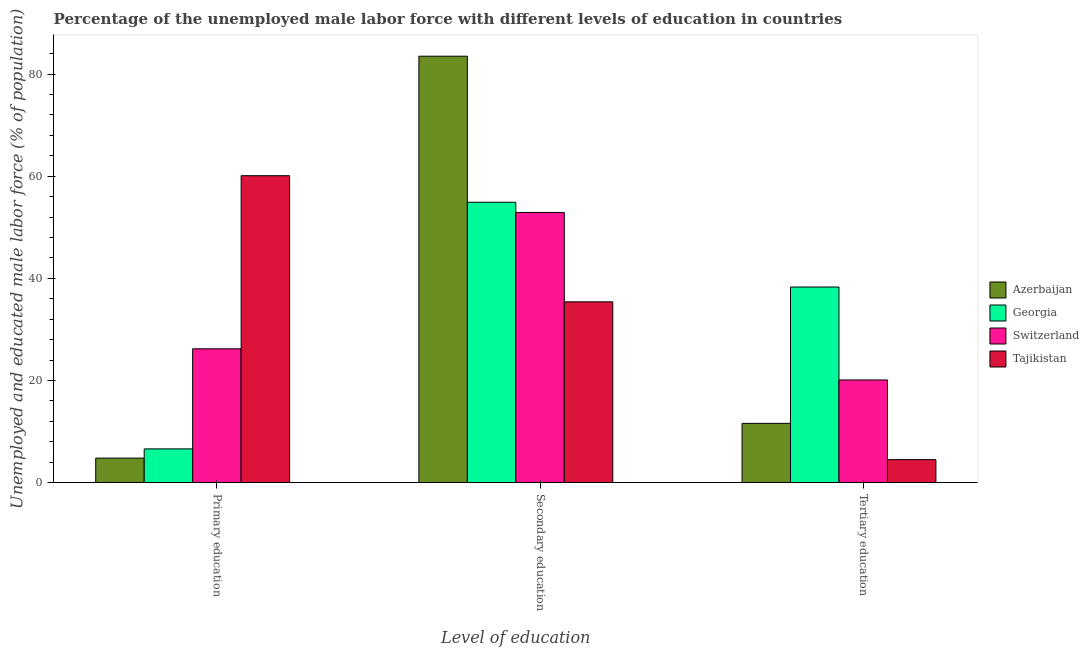How many different coloured bars are there?
Keep it short and to the point. 4. How many groups of bars are there?
Give a very brief answer. 3. Are the number of bars on each tick of the X-axis equal?
Your response must be concise. Yes. What is the label of the 3rd group of bars from the left?
Provide a short and direct response. Tertiary education. What is the percentage of male labor force who received secondary education in Tajikistan?
Ensure brevity in your answer.  35.4. Across all countries, what is the maximum percentage of male labor force who received tertiary education?
Make the answer very short. 38.3. In which country was the percentage of male labor force who received primary education maximum?
Ensure brevity in your answer.  Tajikistan. In which country was the percentage of male labor force who received tertiary education minimum?
Provide a short and direct response. Tajikistan. What is the total percentage of male labor force who received primary education in the graph?
Provide a short and direct response. 97.7. What is the difference between the percentage of male labor force who received tertiary education in Azerbaijan and that in Switzerland?
Your answer should be very brief. -8.5. What is the difference between the percentage of male labor force who received secondary education in Azerbaijan and the percentage of male labor force who received tertiary education in Switzerland?
Your response must be concise. 63.4. What is the average percentage of male labor force who received secondary education per country?
Your answer should be very brief. 56.68. What is the difference between the percentage of male labor force who received secondary education and percentage of male labor force who received primary education in Tajikistan?
Your answer should be compact. -24.7. What is the ratio of the percentage of male labor force who received secondary education in Azerbaijan to that in Switzerland?
Your answer should be compact. 1.58. What is the difference between the highest and the second highest percentage of male labor force who received primary education?
Offer a very short reply. 33.9. What is the difference between the highest and the lowest percentage of male labor force who received primary education?
Your answer should be compact. 55.3. In how many countries, is the percentage of male labor force who received secondary education greater than the average percentage of male labor force who received secondary education taken over all countries?
Ensure brevity in your answer.  1. What does the 4th bar from the left in Primary education represents?
Make the answer very short. Tajikistan. What does the 4th bar from the right in Secondary education represents?
Keep it short and to the point. Azerbaijan. How many bars are there?
Give a very brief answer. 12. Are all the bars in the graph horizontal?
Your answer should be very brief. No. How many countries are there in the graph?
Make the answer very short. 4. What is the difference between two consecutive major ticks on the Y-axis?
Give a very brief answer. 20. Does the graph contain any zero values?
Keep it short and to the point. No. Does the graph contain grids?
Ensure brevity in your answer.  No. How are the legend labels stacked?
Provide a succinct answer. Vertical. What is the title of the graph?
Provide a short and direct response. Percentage of the unemployed male labor force with different levels of education in countries. What is the label or title of the X-axis?
Your answer should be very brief. Level of education. What is the label or title of the Y-axis?
Offer a terse response. Unemployed and educated male labor force (% of population). What is the Unemployed and educated male labor force (% of population) of Azerbaijan in Primary education?
Your answer should be very brief. 4.8. What is the Unemployed and educated male labor force (% of population) in Georgia in Primary education?
Your response must be concise. 6.6. What is the Unemployed and educated male labor force (% of population) in Switzerland in Primary education?
Provide a short and direct response. 26.2. What is the Unemployed and educated male labor force (% of population) of Tajikistan in Primary education?
Your response must be concise. 60.1. What is the Unemployed and educated male labor force (% of population) of Azerbaijan in Secondary education?
Your answer should be compact. 83.5. What is the Unemployed and educated male labor force (% of population) in Georgia in Secondary education?
Ensure brevity in your answer.  54.9. What is the Unemployed and educated male labor force (% of population) in Switzerland in Secondary education?
Your response must be concise. 52.9. What is the Unemployed and educated male labor force (% of population) of Tajikistan in Secondary education?
Your answer should be very brief. 35.4. What is the Unemployed and educated male labor force (% of population) in Azerbaijan in Tertiary education?
Provide a succinct answer. 11.6. What is the Unemployed and educated male labor force (% of population) in Georgia in Tertiary education?
Your answer should be very brief. 38.3. What is the Unemployed and educated male labor force (% of population) in Switzerland in Tertiary education?
Keep it short and to the point. 20.1. Across all Level of education, what is the maximum Unemployed and educated male labor force (% of population) of Azerbaijan?
Your answer should be compact. 83.5. Across all Level of education, what is the maximum Unemployed and educated male labor force (% of population) in Georgia?
Provide a succinct answer. 54.9. Across all Level of education, what is the maximum Unemployed and educated male labor force (% of population) of Switzerland?
Offer a terse response. 52.9. Across all Level of education, what is the maximum Unemployed and educated male labor force (% of population) of Tajikistan?
Offer a terse response. 60.1. Across all Level of education, what is the minimum Unemployed and educated male labor force (% of population) in Azerbaijan?
Make the answer very short. 4.8. Across all Level of education, what is the minimum Unemployed and educated male labor force (% of population) of Georgia?
Keep it short and to the point. 6.6. Across all Level of education, what is the minimum Unemployed and educated male labor force (% of population) of Switzerland?
Give a very brief answer. 20.1. Across all Level of education, what is the minimum Unemployed and educated male labor force (% of population) of Tajikistan?
Your response must be concise. 4.5. What is the total Unemployed and educated male labor force (% of population) in Azerbaijan in the graph?
Provide a short and direct response. 99.9. What is the total Unemployed and educated male labor force (% of population) of Georgia in the graph?
Offer a terse response. 99.8. What is the total Unemployed and educated male labor force (% of population) of Switzerland in the graph?
Your response must be concise. 99.2. What is the total Unemployed and educated male labor force (% of population) in Tajikistan in the graph?
Keep it short and to the point. 100. What is the difference between the Unemployed and educated male labor force (% of population) in Azerbaijan in Primary education and that in Secondary education?
Offer a very short reply. -78.7. What is the difference between the Unemployed and educated male labor force (% of population) of Georgia in Primary education and that in Secondary education?
Your response must be concise. -48.3. What is the difference between the Unemployed and educated male labor force (% of population) in Switzerland in Primary education and that in Secondary education?
Keep it short and to the point. -26.7. What is the difference between the Unemployed and educated male labor force (% of population) in Tajikistan in Primary education and that in Secondary education?
Your answer should be very brief. 24.7. What is the difference between the Unemployed and educated male labor force (% of population) in Azerbaijan in Primary education and that in Tertiary education?
Give a very brief answer. -6.8. What is the difference between the Unemployed and educated male labor force (% of population) of Georgia in Primary education and that in Tertiary education?
Provide a succinct answer. -31.7. What is the difference between the Unemployed and educated male labor force (% of population) of Tajikistan in Primary education and that in Tertiary education?
Your answer should be compact. 55.6. What is the difference between the Unemployed and educated male labor force (% of population) of Azerbaijan in Secondary education and that in Tertiary education?
Give a very brief answer. 71.9. What is the difference between the Unemployed and educated male labor force (% of population) in Switzerland in Secondary education and that in Tertiary education?
Ensure brevity in your answer.  32.8. What is the difference between the Unemployed and educated male labor force (% of population) of Tajikistan in Secondary education and that in Tertiary education?
Keep it short and to the point. 30.9. What is the difference between the Unemployed and educated male labor force (% of population) in Azerbaijan in Primary education and the Unemployed and educated male labor force (% of population) in Georgia in Secondary education?
Ensure brevity in your answer.  -50.1. What is the difference between the Unemployed and educated male labor force (% of population) of Azerbaijan in Primary education and the Unemployed and educated male labor force (% of population) of Switzerland in Secondary education?
Your answer should be very brief. -48.1. What is the difference between the Unemployed and educated male labor force (% of population) of Azerbaijan in Primary education and the Unemployed and educated male labor force (% of population) of Tajikistan in Secondary education?
Provide a succinct answer. -30.6. What is the difference between the Unemployed and educated male labor force (% of population) of Georgia in Primary education and the Unemployed and educated male labor force (% of population) of Switzerland in Secondary education?
Give a very brief answer. -46.3. What is the difference between the Unemployed and educated male labor force (% of population) in Georgia in Primary education and the Unemployed and educated male labor force (% of population) in Tajikistan in Secondary education?
Keep it short and to the point. -28.8. What is the difference between the Unemployed and educated male labor force (% of population) of Switzerland in Primary education and the Unemployed and educated male labor force (% of population) of Tajikistan in Secondary education?
Make the answer very short. -9.2. What is the difference between the Unemployed and educated male labor force (% of population) of Azerbaijan in Primary education and the Unemployed and educated male labor force (% of population) of Georgia in Tertiary education?
Provide a short and direct response. -33.5. What is the difference between the Unemployed and educated male labor force (% of population) of Azerbaijan in Primary education and the Unemployed and educated male labor force (% of population) of Switzerland in Tertiary education?
Provide a succinct answer. -15.3. What is the difference between the Unemployed and educated male labor force (% of population) in Georgia in Primary education and the Unemployed and educated male labor force (% of population) in Switzerland in Tertiary education?
Keep it short and to the point. -13.5. What is the difference between the Unemployed and educated male labor force (% of population) in Georgia in Primary education and the Unemployed and educated male labor force (% of population) in Tajikistan in Tertiary education?
Make the answer very short. 2.1. What is the difference between the Unemployed and educated male labor force (% of population) in Switzerland in Primary education and the Unemployed and educated male labor force (% of population) in Tajikistan in Tertiary education?
Your answer should be compact. 21.7. What is the difference between the Unemployed and educated male labor force (% of population) of Azerbaijan in Secondary education and the Unemployed and educated male labor force (% of population) of Georgia in Tertiary education?
Make the answer very short. 45.2. What is the difference between the Unemployed and educated male labor force (% of population) in Azerbaijan in Secondary education and the Unemployed and educated male labor force (% of population) in Switzerland in Tertiary education?
Keep it short and to the point. 63.4. What is the difference between the Unemployed and educated male labor force (% of population) in Azerbaijan in Secondary education and the Unemployed and educated male labor force (% of population) in Tajikistan in Tertiary education?
Keep it short and to the point. 79. What is the difference between the Unemployed and educated male labor force (% of population) in Georgia in Secondary education and the Unemployed and educated male labor force (% of population) in Switzerland in Tertiary education?
Your response must be concise. 34.8. What is the difference between the Unemployed and educated male labor force (% of population) of Georgia in Secondary education and the Unemployed and educated male labor force (% of population) of Tajikistan in Tertiary education?
Provide a short and direct response. 50.4. What is the difference between the Unemployed and educated male labor force (% of population) of Switzerland in Secondary education and the Unemployed and educated male labor force (% of population) of Tajikistan in Tertiary education?
Give a very brief answer. 48.4. What is the average Unemployed and educated male labor force (% of population) of Azerbaijan per Level of education?
Keep it short and to the point. 33.3. What is the average Unemployed and educated male labor force (% of population) of Georgia per Level of education?
Your answer should be very brief. 33.27. What is the average Unemployed and educated male labor force (% of population) in Switzerland per Level of education?
Offer a very short reply. 33.07. What is the average Unemployed and educated male labor force (% of population) of Tajikistan per Level of education?
Your answer should be very brief. 33.33. What is the difference between the Unemployed and educated male labor force (% of population) of Azerbaijan and Unemployed and educated male labor force (% of population) of Switzerland in Primary education?
Your answer should be very brief. -21.4. What is the difference between the Unemployed and educated male labor force (% of population) in Azerbaijan and Unemployed and educated male labor force (% of population) in Tajikistan in Primary education?
Ensure brevity in your answer.  -55.3. What is the difference between the Unemployed and educated male labor force (% of population) in Georgia and Unemployed and educated male labor force (% of population) in Switzerland in Primary education?
Your answer should be compact. -19.6. What is the difference between the Unemployed and educated male labor force (% of population) in Georgia and Unemployed and educated male labor force (% of population) in Tajikistan in Primary education?
Give a very brief answer. -53.5. What is the difference between the Unemployed and educated male labor force (% of population) of Switzerland and Unemployed and educated male labor force (% of population) of Tajikistan in Primary education?
Provide a succinct answer. -33.9. What is the difference between the Unemployed and educated male labor force (% of population) of Azerbaijan and Unemployed and educated male labor force (% of population) of Georgia in Secondary education?
Keep it short and to the point. 28.6. What is the difference between the Unemployed and educated male labor force (% of population) in Azerbaijan and Unemployed and educated male labor force (% of population) in Switzerland in Secondary education?
Make the answer very short. 30.6. What is the difference between the Unemployed and educated male labor force (% of population) in Azerbaijan and Unemployed and educated male labor force (% of population) in Tajikistan in Secondary education?
Make the answer very short. 48.1. What is the difference between the Unemployed and educated male labor force (% of population) in Georgia and Unemployed and educated male labor force (% of population) in Tajikistan in Secondary education?
Make the answer very short. 19.5. What is the difference between the Unemployed and educated male labor force (% of population) of Azerbaijan and Unemployed and educated male labor force (% of population) of Georgia in Tertiary education?
Give a very brief answer. -26.7. What is the difference between the Unemployed and educated male labor force (% of population) in Georgia and Unemployed and educated male labor force (% of population) in Switzerland in Tertiary education?
Your response must be concise. 18.2. What is the difference between the Unemployed and educated male labor force (% of population) in Georgia and Unemployed and educated male labor force (% of population) in Tajikistan in Tertiary education?
Give a very brief answer. 33.8. What is the difference between the Unemployed and educated male labor force (% of population) in Switzerland and Unemployed and educated male labor force (% of population) in Tajikistan in Tertiary education?
Ensure brevity in your answer.  15.6. What is the ratio of the Unemployed and educated male labor force (% of population) in Azerbaijan in Primary education to that in Secondary education?
Provide a succinct answer. 0.06. What is the ratio of the Unemployed and educated male labor force (% of population) in Georgia in Primary education to that in Secondary education?
Give a very brief answer. 0.12. What is the ratio of the Unemployed and educated male labor force (% of population) in Switzerland in Primary education to that in Secondary education?
Give a very brief answer. 0.5. What is the ratio of the Unemployed and educated male labor force (% of population) of Tajikistan in Primary education to that in Secondary education?
Make the answer very short. 1.7. What is the ratio of the Unemployed and educated male labor force (% of population) of Azerbaijan in Primary education to that in Tertiary education?
Keep it short and to the point. 0.41. What is the ratio of the Unemployed and educated male labor force (% of population) in Georgia in Primary education to that in Tertiary education?
Offer a very short reply. 0.17. What is the ratio of the Unemployed and educated male labor force (% of population) in Switzerland in Primary education to that in Tertiary education?
Provide a succinct answer. 1.3. What is the ratio of the Unemployed and educated male labor force (% of population) in Tajikistan in Primary education to that in Tertiary education?
Provide a succinct answer. 13.36. What is the ratio of the Unemployed and educated male labor force (% of population) of Azerbaijan in Secondary education to that in Tertiary education?
Offer a terse response. 7.2. What is the ratio of the Unemployed and educated male labor force (% of population) of Georgia in Secondary education to that in Tertiary education?
Keep it short and to the point. 1.43. What is the ratio of the Unemployed and educated male labor force (% of population) of Switzerland in Secondary education to that in Tertiary education?
Provide a succinct answer. 2.63. What is the ratio of the Unemployed and educated male labor force (% of population) of Tajikistan in Secondary education to that in Tertiary education?
Offer a very short reply. 7.87. What is the difference between the highest and the second highest Unemployed and educated male labor force (% of population) of Azerbaijan?
Keep it short and to the point. 71.9. What is the difference between the highest and the second highest Unemployed and educated male labor force (% of population) in Switzerland?
Your answer should be very brief. 26.7. What is the difference between the highest and the second highest Unemployed and educated male labor force (% of population) in Tajikistan?
Your answer should be compact. 24.7. What is the difference between the highest and the lowest Unemployed and educated male labor force (% of population) of Azerbaijan?
Offer a terse response. 78.7. What is the difference between the highest and the lowest Unemployed and educated male labor force (% of population) in Georgia?
Provide a succinct answer. 48.3. What is the difference between the highest and the lowest Unemployed and educated male labor force (% of population) in Switzerland?
Your answer should be compact. 32.8. What is the difference between the highest and the lowest Unemployed and educated male labor force (% of population) in Tajikistan?
Your answer should be compact. 55.6. 